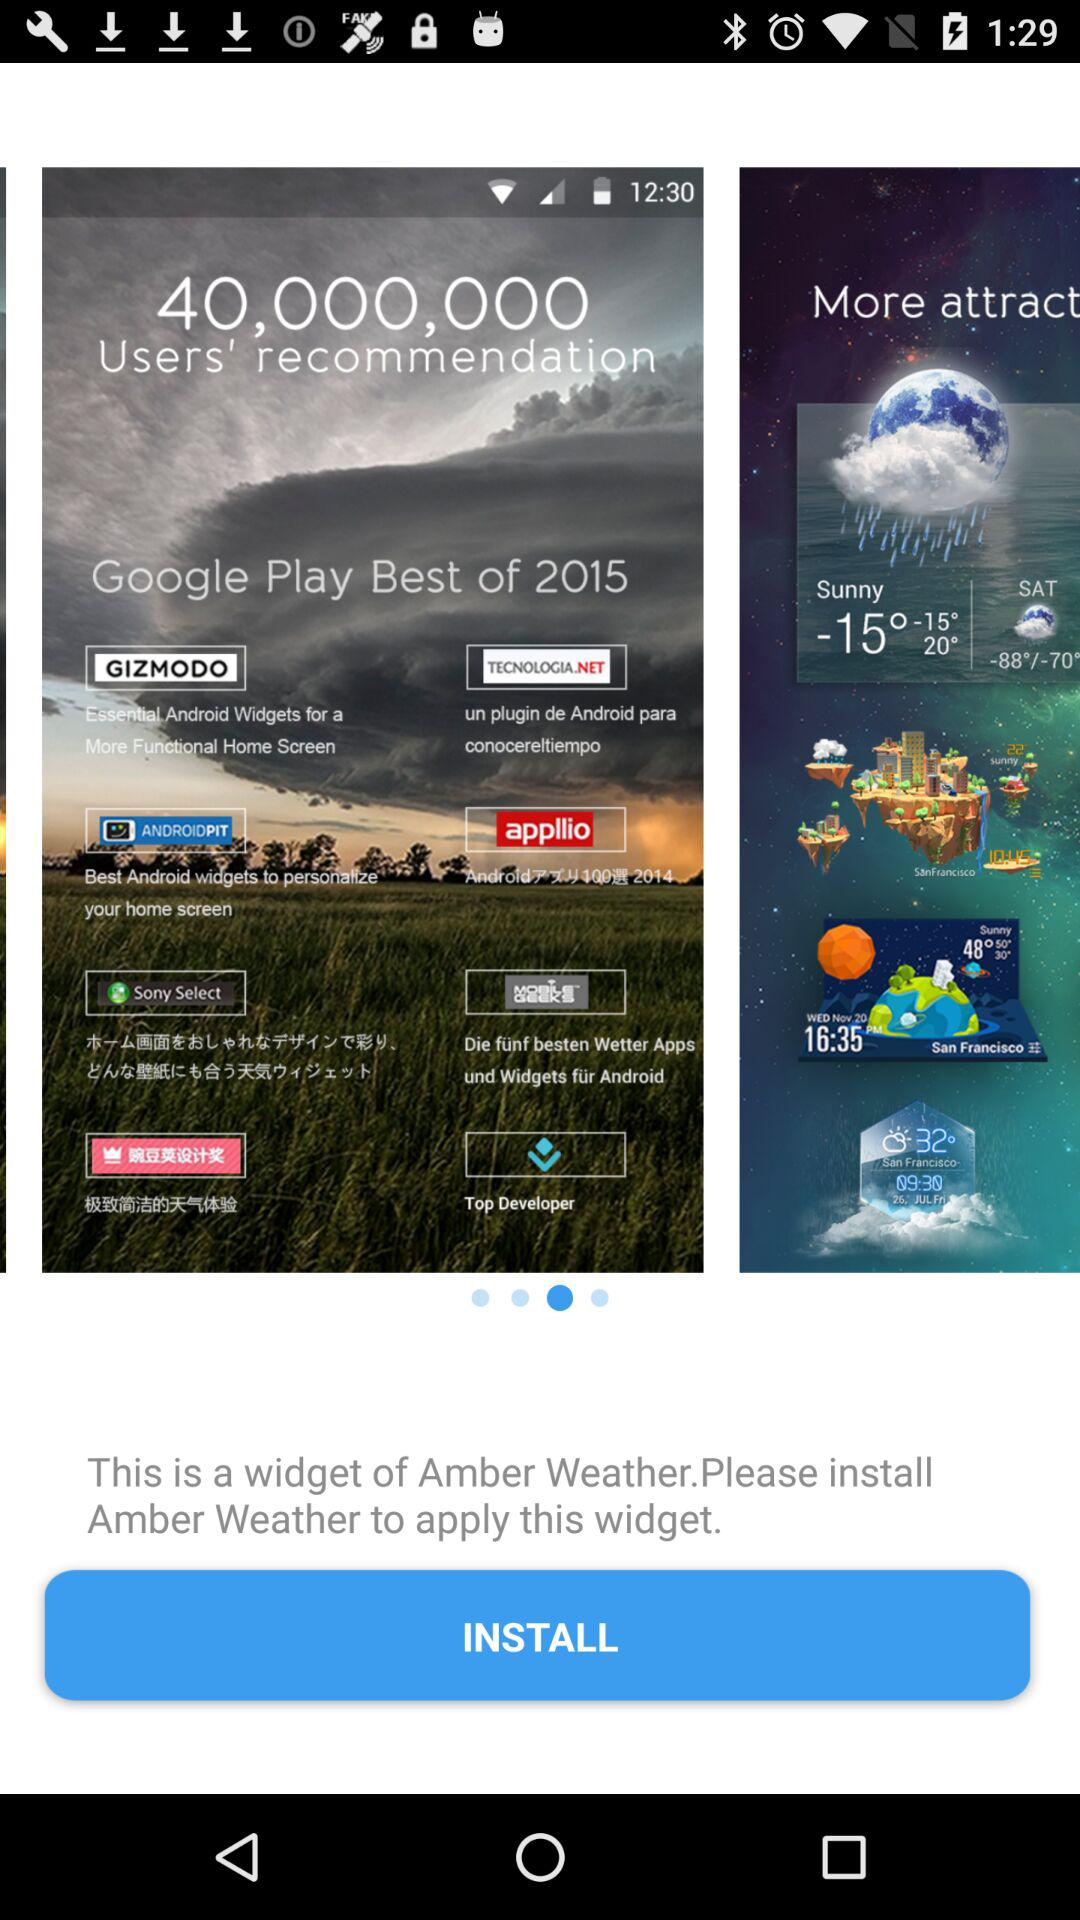What is the temperature on Saturday? The temperature on Saturday ranges from -88° to -70°. 